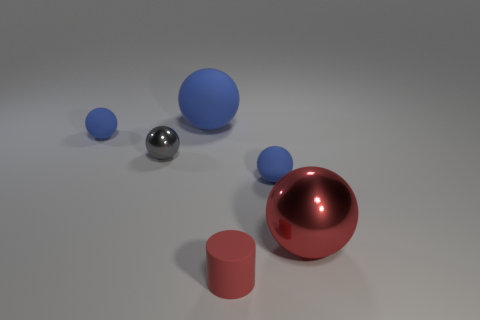Does the small matte cylinder have the same color as the large metal object?
Offer a very short reply. Yes. What shape is the gray shiny object that is the same size as the cylinder?
Your answer should be compact. Sphere. Is there a tiny blue rubber thing of the same shape as the big blue rubber object?
Ensure brevity in your answer.  Yes. Does the big sphere that is in front of the large blue thing have the same color as the small rubber cylinder that is to the right of the small gray metallic object?
Make the answer very short. Yes. There is a red metal sphere; are there any blue objects to the left of it?
Your response must be concise. Yes. There is a object that is both behind the gray ball and to the left of the big blue matte thing; what material is it?
Keep it short and to the point. Rubber. Are the tiny gray object that is on the left side of the small red matte cylinder and the large red ball made of the same material?
Keep it short and to the point. Yes. What material is the cylinder?
Offer a very short reply. Rubber. How big is the blue rubber ball that is on the left side of the big blue ball?
Give a very brief answer. Small. Are there any other things that are the same color as the cylinder?
Your answer should be compact. Yes. 